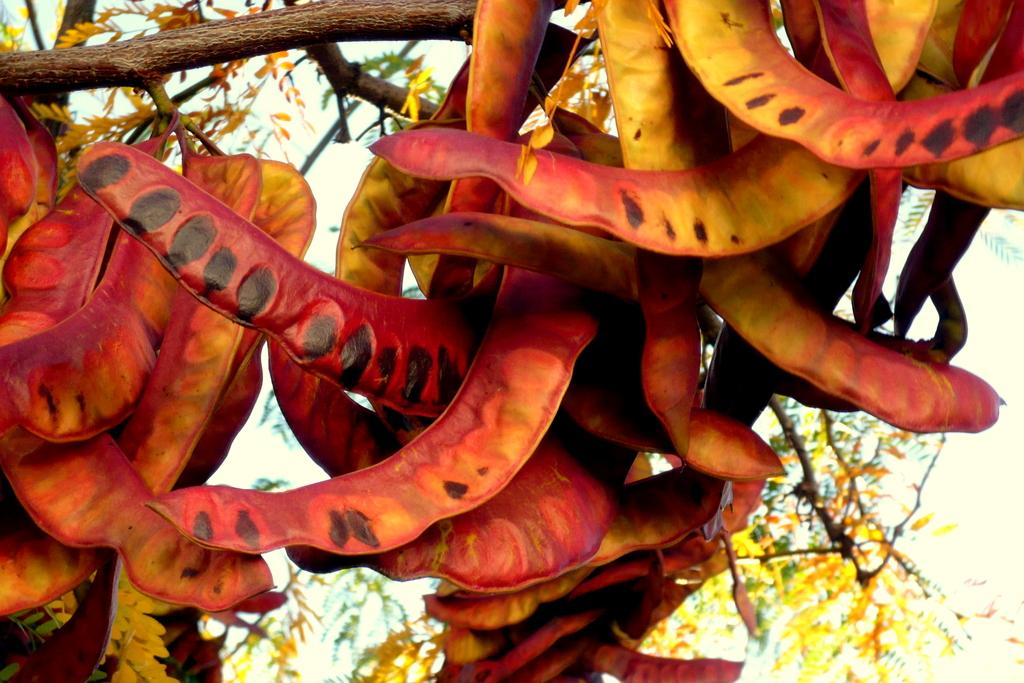What type of plant is visible on the branch in the image? There are beans on the branch of a tree in the image. What can be seen at the top of the image? The sky is visible at the top of the image. How many fingers can be seen holding the beans in the image? There are no fingers visible in the image; the beans are on the branch of a tree. 